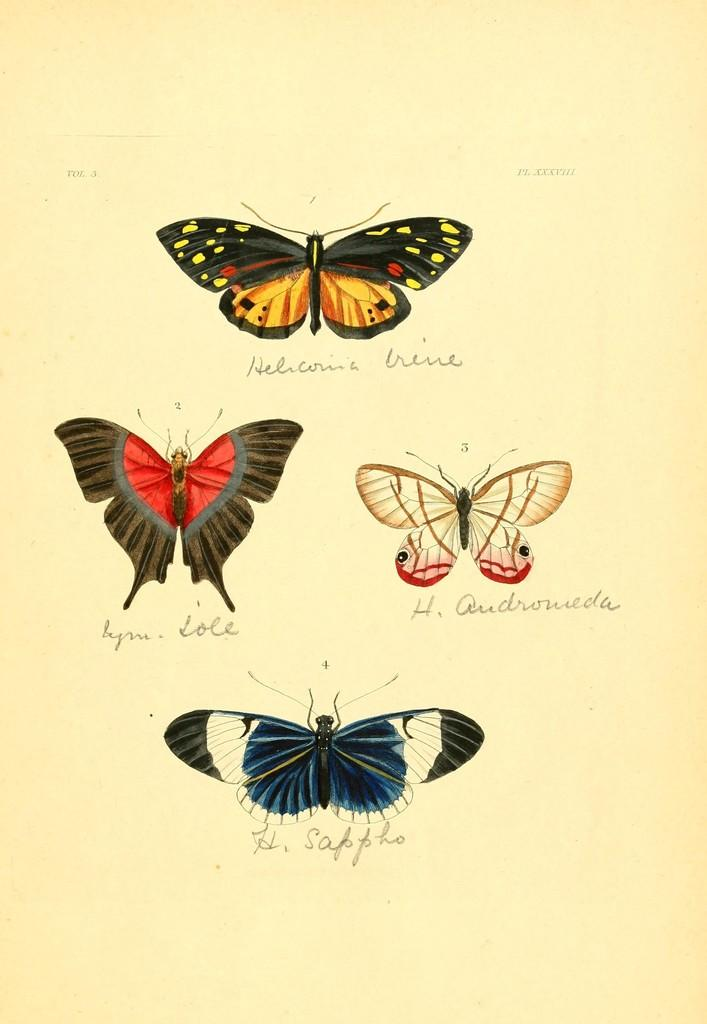What is depicted in the image? There is a picture of butterflies in the image. What else can be found on the image besides the butterflies? There is text on the image. What type of silk can be seen on the edge of the apples in the image? There are no apples or silk present in the image; it only features a picture of butterflies and text. 